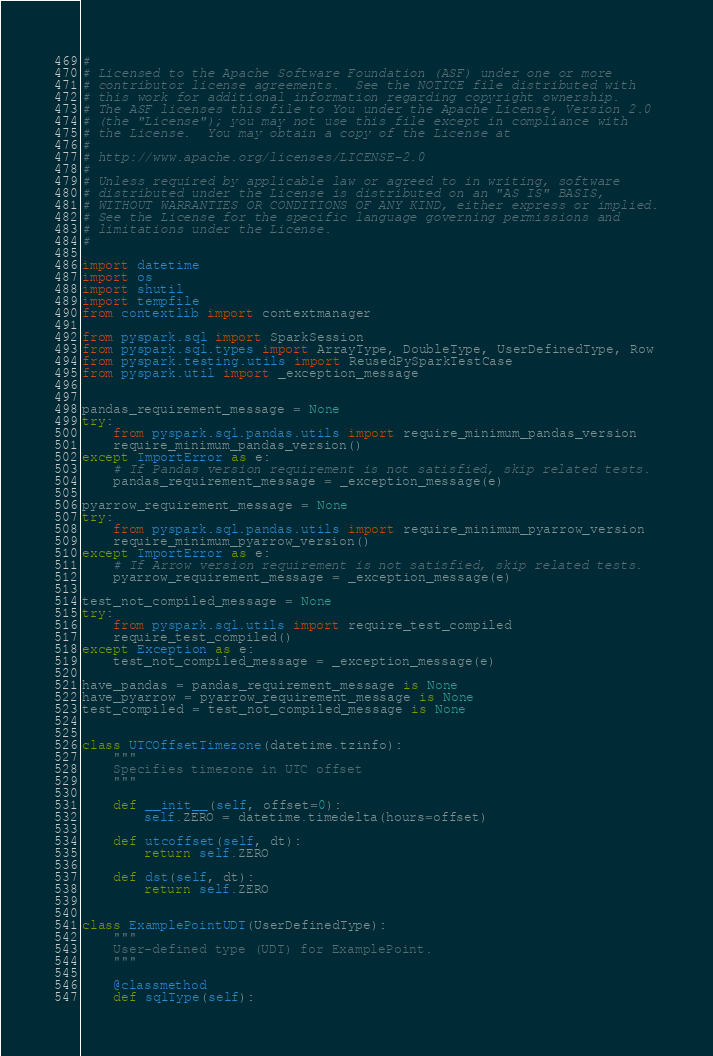Convert code to text. <code><loc_0><loc_0><loc_500><loc_500><_Python_>#
# Licensed to the Apache Software Foundation (ASF) under one or more
# contributor license agreements.  See the NOTICE file distributed with
# this work for additional information regarding copyright ownership.
# The ASF licenses this file to You under the Apache License, Version 2.0
# (the "License"); you may not use this file except in compliance with
# the License.  You may obtain a copy of the License at
#
# http://www.apache.org/licenses/LICENSE-2.0
#
# Unless required by applicable law or agreed to in writing, software
# distributed under the License is distributed on an "AS IS" BASIS,
# WITHOUT WARRANTIES OR CONDITIONS OF ANY KIND, either express or implied.
# See the License for the specific language governing permissions and
# limitations under the License.
#

import datetime
import os
import shutil
import tempfile
from contextlib import contextmanager

from pyspark.sql import SparkSession
from pyspark.sql.types import ArrayType, DoubleType, UserDefinedType, Row
from pyspark.testing.utils import ReusedPySparkTestCase
from pyspark.util import _exception_message


pandas_requirement_message = None
try:
    from pyspark.sql.pandas.utils import require_minimum_pandas_version
    require_minimum_pandas_version()
except ImportError as e:
    # If Pandas version requirement is not satisfied, skip related tests.
    pandas_requirement_message = _exception_message(e)

pyarrow_requirement_message = None
try:
    from pyspark.sql.pandas.utils import require_minimum_pyarrow_version
    require_minimum_pyarrow_version()
except ImportError as e:
    # If Arrow version requirement is not satisfied, skip related tests.
    pyarrow_requirement_message = _exception_message(e)

test_not_compiled_message = None
try:
    from pyspark.sql.utils import require_test_compiled
    require_test_compiled()
except Exception as e:
    test_not_compiled_message = _exception_message(e)

have_pandas = pandas_requirement_message is None
have_pyarrow = pyarrow_requirement_message is None
test_compiled = test_not_compiled_message is None


class UTCOffsetTimezone(datetime.tzinfo):
    """
    Specifies timezone in UTC offset
    """

    def __init__(self, offset=0):
        self.ZERO = datetime.timedelta(hours=offset)

    def utcoffset(self, dt):
        return self.ZERO

    def dst(self, dt):
        return self.ZERO


class ExamplePointUDT(UserDefinedType):
    """
    User-defined type (UDT) for ExamplePoint.
    """

    @classmethod
    def sqlType(self):</code> 